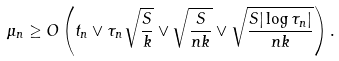<formula> <loc_0><loc_0><loc_500><loc_500>\mu _ { n } \geq O \left ( t _ { n } \vee \tau _ { n } \sqrt { \frac { S } { k } } \vee \sqrt { \frac { S } { n k } } \vee \sqrt { \frac { S | \log { \tau _ { n } } | } { n k } } \right ) .</formula> 